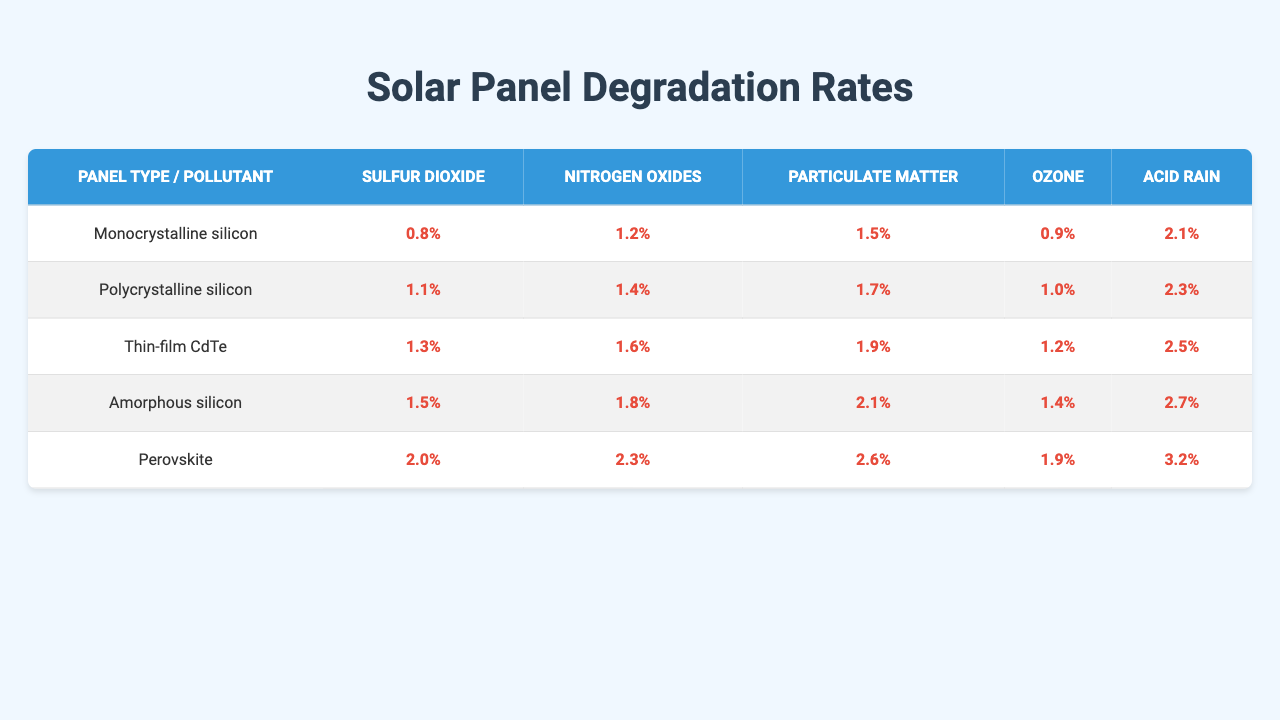What is the highest degradation rate for monocrystalline silicon panels? The degradation rates for monocrystalline silicon panels across the different pollutants are 0.8%, 1.1%, 1.3%, 1.5%, and 2.0%. The highest value among these is 2.0%.
Answer: 2.0% Which pollutant has the lowest degradation rate for thin-film CdTe panels? The degradation rates for thin-film CdTe panels are 1.5%, 1.7%, 1.9%, 2.1%, and 2.6% across the pollutants. The lowest among these is 1.5% for sulfur dioxide.
Answer: 1.5% What is the average degradation rate for acid rain across all panel types? The degradation rates for acid rain across the five panel types are 2.1%, 2.3%, 2.5%, 2.7%, and 3.2%. The average is calculated by summing these values (2.1 + 2.3 + 2.5 + 2.7 + 3.2 = 12.8) and dividing by 5, resulting in 12.8 / 5 = 2.56%.
Answer: 2.56% Which panel type is the most affected by particulate matter, and what is the degradation rate? Checking the degradation rates for particulate matter across all panel types reveals values of 1.5% for monocrystalline, 1.7% for polycrystalline, 1.9% for thin-film CdTe, 2.1% for amorphous silicon, and 2.6% for perovskite. The highest rate is 2.6% for perovskite panels.
Answer: Perovskite, 2.6% Is it true that nitrogen oxides have the same degradation rate for both monocrystalline and polycrystalline silicon panels? The degradation rates for nitrogen oxides are 1.2% for monocrystalline silicon and 1.4% for polycrystalline silicon. Since these rates are different, the statement is false.
Answer: No What is the degradation rate difference for ozone between thin-film CdTe and amorphous silicon panels? The degradation rates for ozone are 1.2% for thin-film CdTe and 1.4% for amorphous silicon panels. The difference between these rates is 1.4% - 1.2% = 0.2%.
Answer: 0.2% How do the average degradation rates for sulfur dioxide and ozone compare across all panel types? The average degradation rates for sulfur dioxide across all panel types are calculated as (0.8 + 1.1 + 1.3 + 1.5 + 2.0) / 5 = 1.54%. The average for ozone is (0.9 + 1.0 + 1.2 + 1.4 + 1.9) / 5 = 1.48%. Since 1.54% is greater than 1.48%, sulfur dioxide has a higher average degradation rate.
Answer: Sulfur dioxide is higher, 1.54% vs. 1.48% Which panel type exhibits the least degradation under the influence of acid rain? The degradation rates for acid rain across the panel types are 2.1%, 2.3%, 2.5%, 2.7%, and 3.2%. The least degradation is observed in monocrystalline silicon with a rate of 2.1%.
Answer: Monocrystalline silicon, 2.1% 